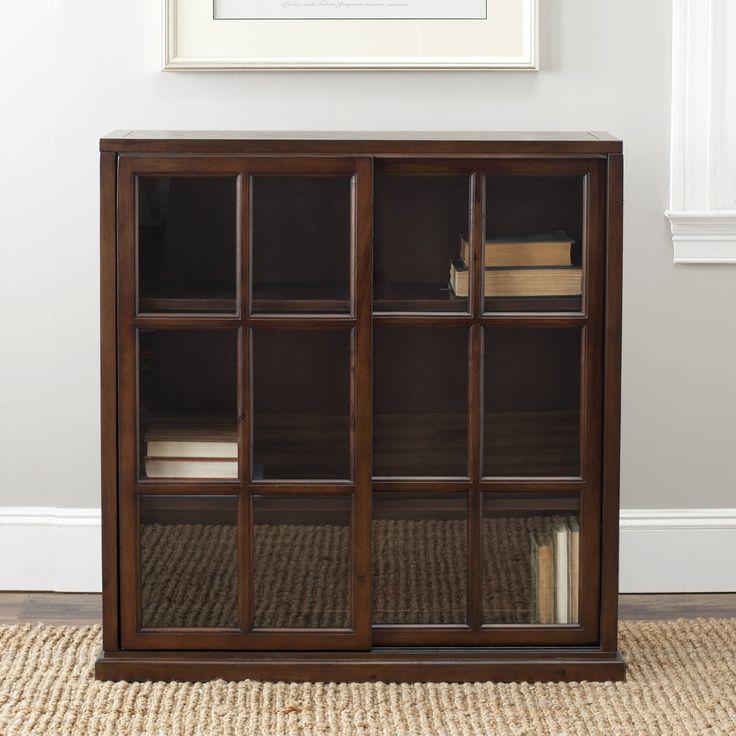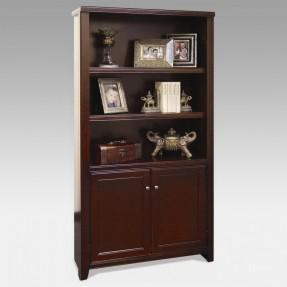The first image is the image on the left, the second image is the image on the right. Evaluate the accuracy of this statement regarding the images: "There is 1 ivory colored chair next to a tall bookcase.". Is it true? Answer yes or no. No. 